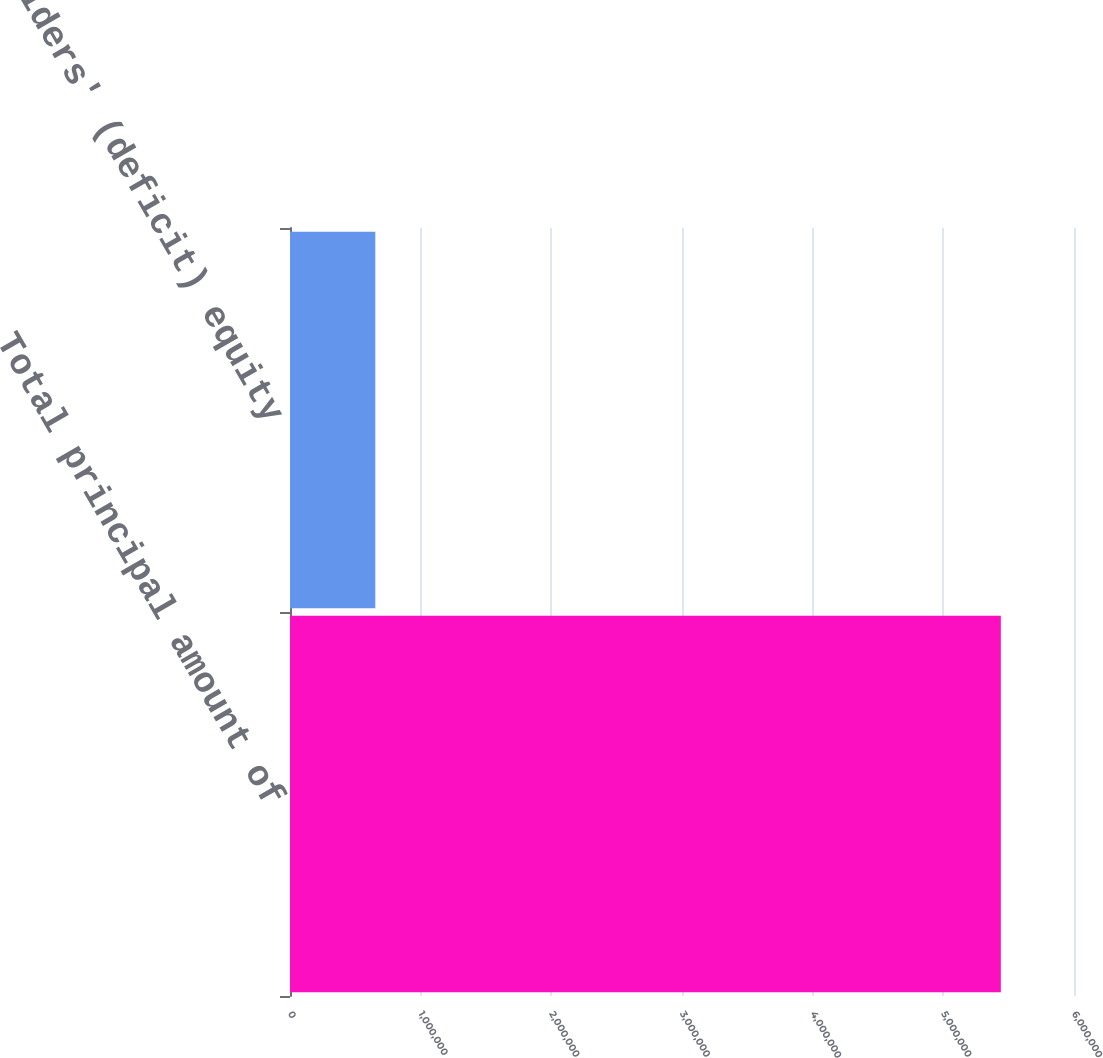Convert chart to OTSL. <chart><loc_0><loc_0><loc_500><loc_500><bar_chart><fcel>Total principal amount of<fcel>Shareholders' (deficit) equity<nl><fcel>5.44007e+06<fcel>652991<nl></chart> 